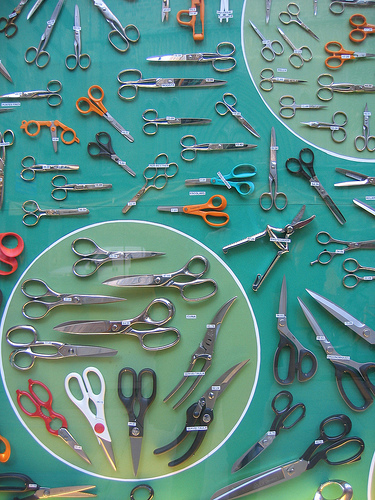Imagine these scissors come to life. What kind of personalities would they have? In this whimsical scenario, each pair of scissors would have its own unique personality. The large black scissors could be seen as the wise and experienced leader, always ready to provide guidance. The red scissors might be the charismatic and lively member, full of energy and enthusiasm. The small orange scissors could be the mischievous and playful ones, always causing a bit of chaos but with a heart of gold. Together, they'd form a vibrant and dynamic team, each contributing to their communal tasks with their distinct traits. 